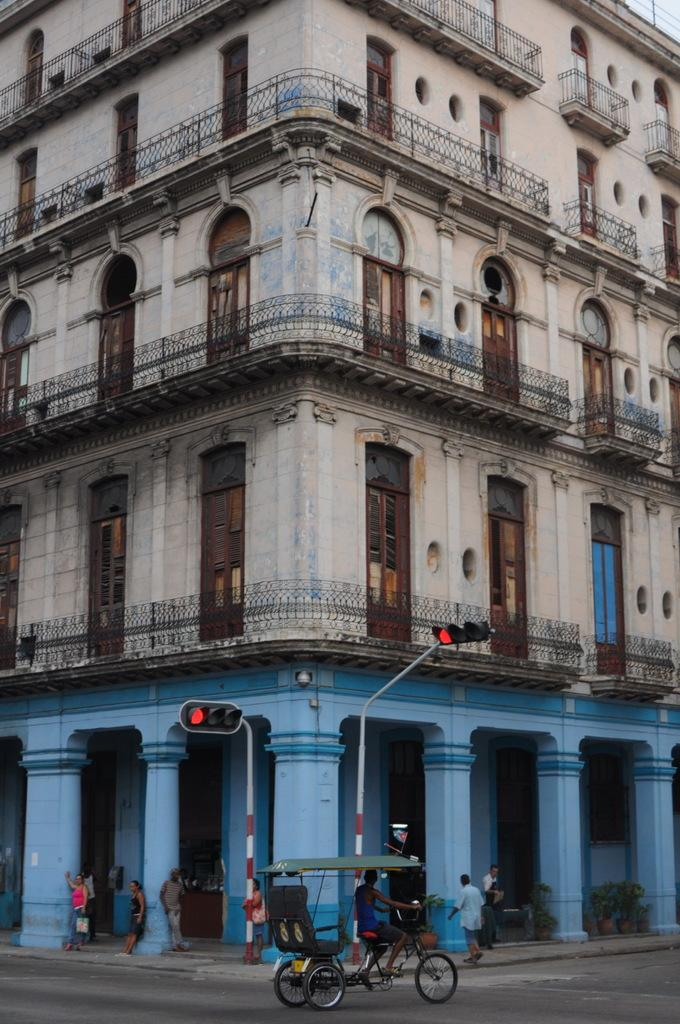What type of structures can be seen in the image? There are buildings in the image. What type of barrier is present in the image? There is a fence in the image. What features are present on the buildings in the image? There are doors and windows in the image. What mode of transportation is visible in the image? A: There is a vehicle in the image. Are there any people present in the image? Yes, there are people in the image. What traffic control devices can be seen in the image? There are traffic signals in the image. Can you tell me how many ploughs are being used by the people in the image? There is no plough present in the image; it features buildings, a fence, doors, windows, a vehicle, traffic signals, and people. What type of underground storage space can be seen in the image? There is no cellar present in the image. 